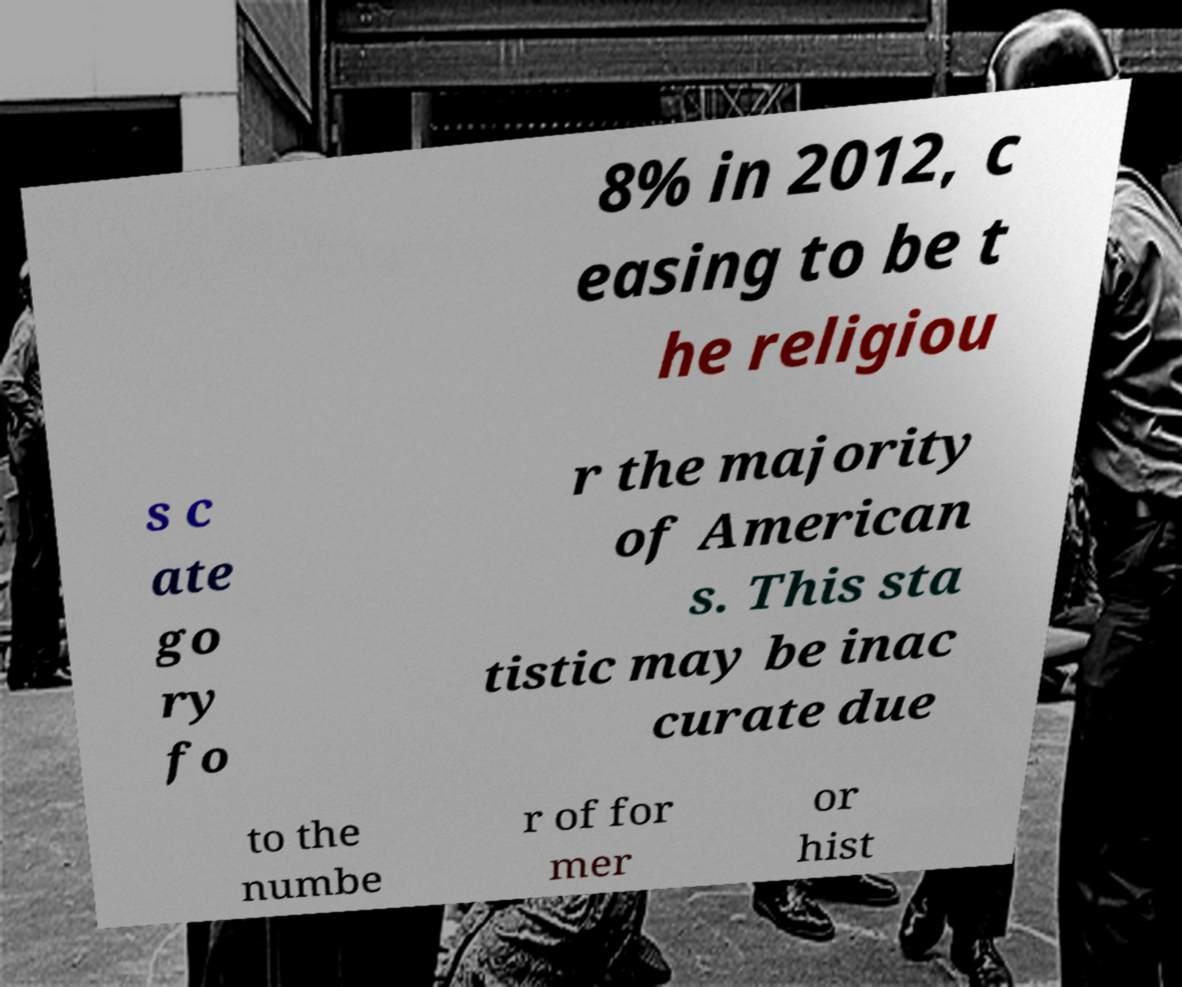Please read and relay the text visible in this image. What does it say? 8% in 2012, c easing to be t he religiou s c ate go ry fo r the majority of American s. This sta tistic may be inac curate due to the numbe r of for mer or hist 